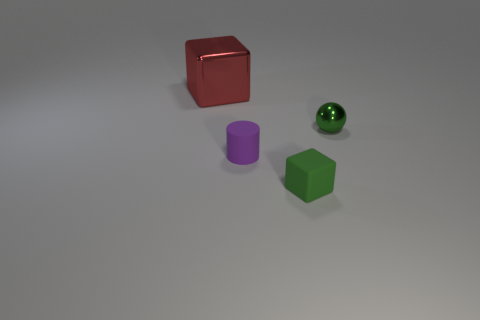Do the purple thing and the big red block have the same material?
Ensure brevity in your answer.  No. Are there any cylinders of the same size as the shiny ball?
Ensure brevity in your answer.  Yes. There is a purple object that is the same size as the green matte object; what material is it?
Your answer should be compact. Rubber. Is there a red shiny thing of the same shape as the green matte object?
Provide a short and direct response. Yes. There is a block that is the same color as the tiny sphere; what is it made of?
Your answer should be compact. Rubber. There is a small rubber thing that is on the left side of the tiny rubber cube; what is its shape?
Provide a short and direct response. Cylinder. What number of small yellow rubber cubes are there?
Provide a succinct answer. 0. There is a thing that is the same material as the small green sphere; what color is it?
Your answer should be compact. Red. What number of large objects are green shiny objects or matte objects?
Your response must be concise. 0. There is a purple cylinder; how many blocks are to the left of it?
Provide a succinct answer. 1. 